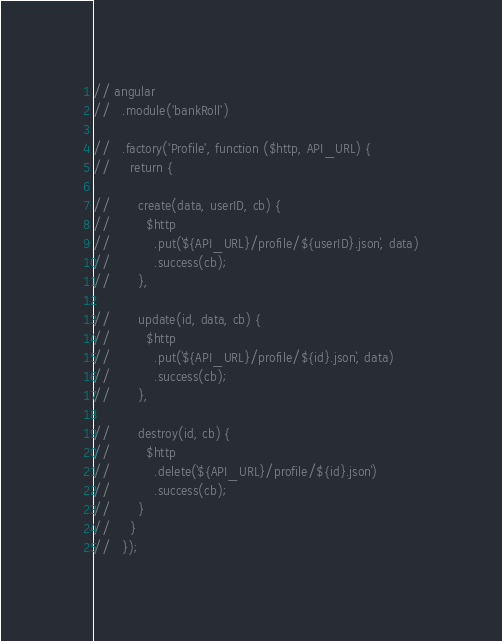<code> <loc_0><loc_0><loc_500><loc_500><_JavaScript_>// angular
//   .module('bankRoll')

//   .factory('Profile', function ($http, API_URL) {
//     return {

//       create(data, userID, cb) {
//         $http
//           .put(`${API_URL}/profile/${userID}.json`, data)
//           .success(cb);
//       },

//       update(id, data, cb) {
//         $http
//           .put(`${API_URL}/profile/${id}.json`, data)
//           .success(cb);
//       },

//       destroy(id, cb) {
//         $http
//           .delete(`${API_URL}/profile/${id}.json`)
//           .success(cb);
//       }
//     }
//   });
</code> 